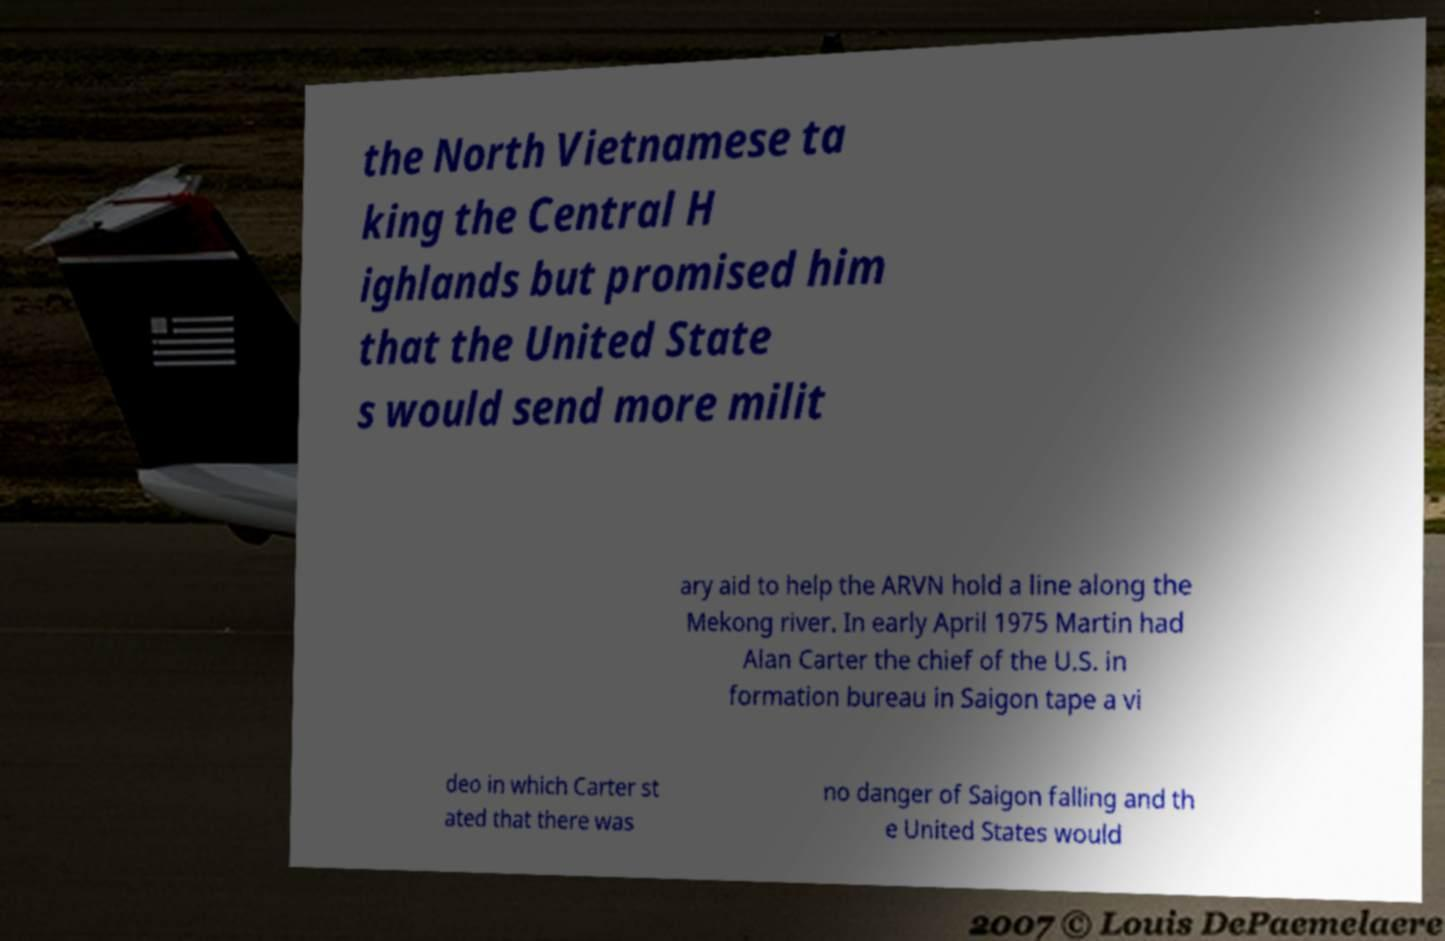There's text embedded in this image that I need extracted. Can you transcribe it verbatim? the North Vietnamese ta king the Central H ighlands but promised him that the United State s would send more milit ary aid to help the ARVN hold a line along the Mekong river. In early April 1975 Martin had Alan Carter the chief of the U.S. in formation bureau in Saigon tape a vi deo in which Carter st ated that there was no danger of Saigon falling and th e United States would 